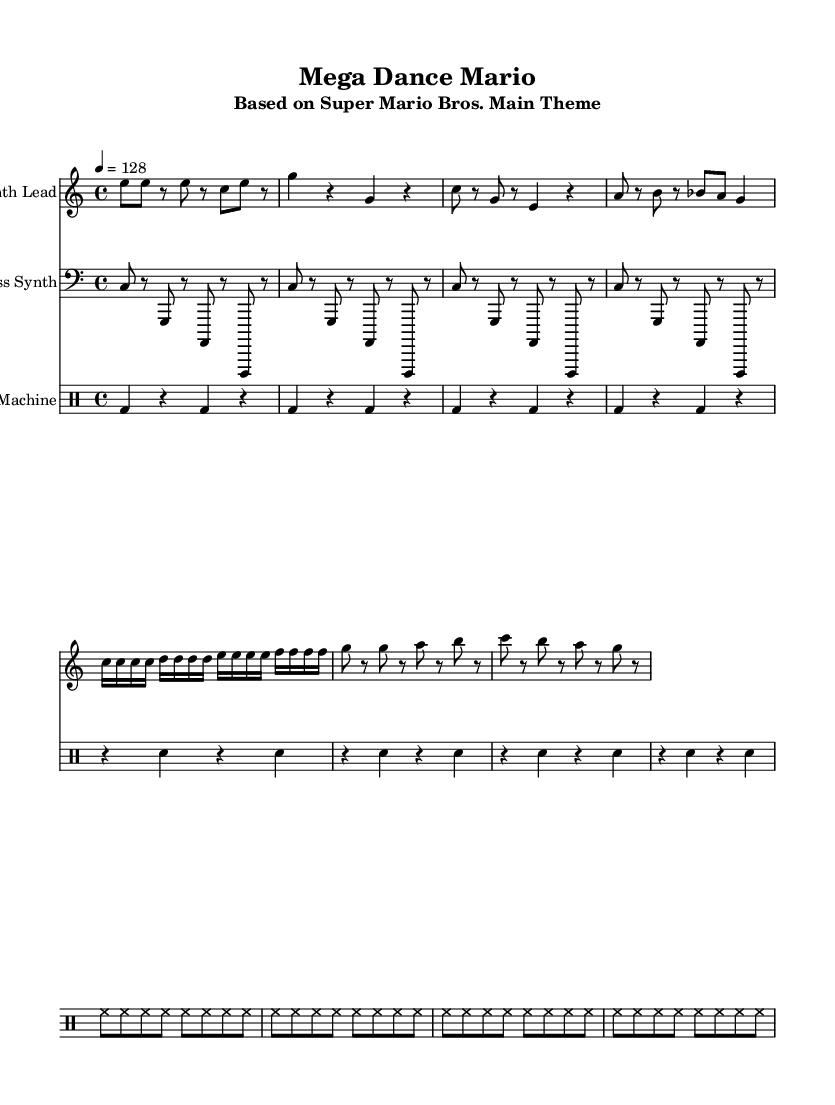What is the key signature of this music? The key signature is C major, which has no sharps or flats.
Answer: C major What is the time signature of this music? The time signature is 4/4, indicating four beats per measure, with each quarter note getting one beat.
Answer: 4/4 What is the tempo marking of this piece? The tempo marking of the piece is indicated as "4 = 128", meaning the quarter note is played at 128 beats per minute.
Answer: 128 How many measures are there in the verse section? The verse consists of two phrases, each with four measures; thus, there are a total of 8 measures in the verse section.
Answer: 8 What instruments are featured in this arrangement? The arrangement includes a Synth Lead, a Bass Synth, and a Drum Machine as the main instruments performing this piece.
Answer: Synth Lead, Bass Synth, Drum Machine What rhythmic pattern is used in the drum machine? The drum machine uses a pattern that includes kick drums on the downbeats, snare drums on the off-beats, and continuous hi-hat notes, creating an energetic dance rhythm.
Answer: Kick, Snare, Hi-hat Which section of the music is considered the "drop"? The section labeled "Drop" features a series of ascending and descending notes that create an energetic climax; it is characterized by the rhythmic emphasis on the note patterns.
Answer: Drop 